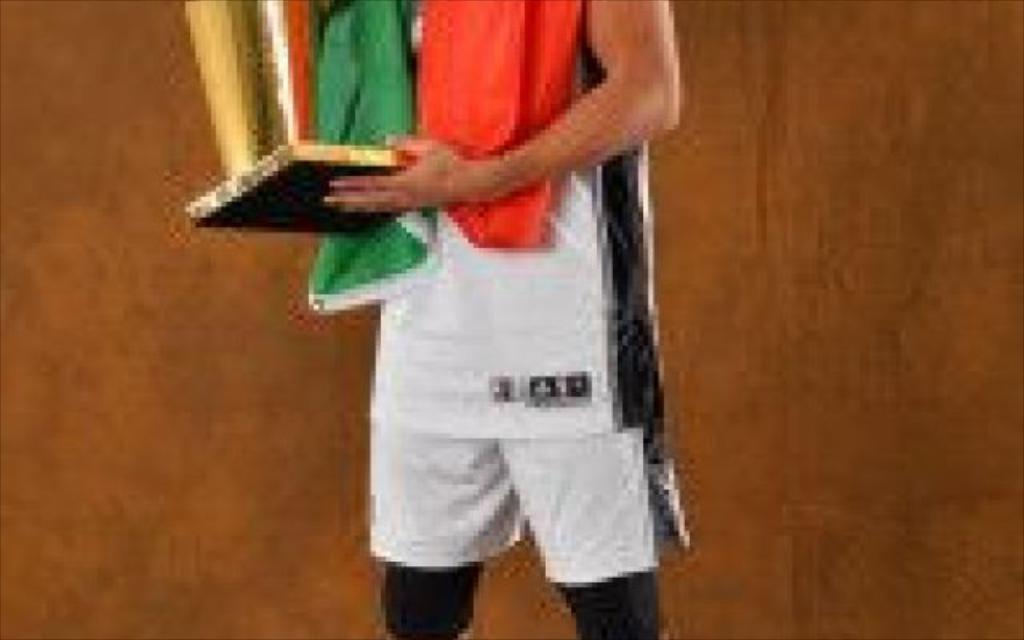In one or two sentences, can you explain what this image depicts? This is a blurred image, we can see a person is holding a trophy and behind the person there is a brown color. 